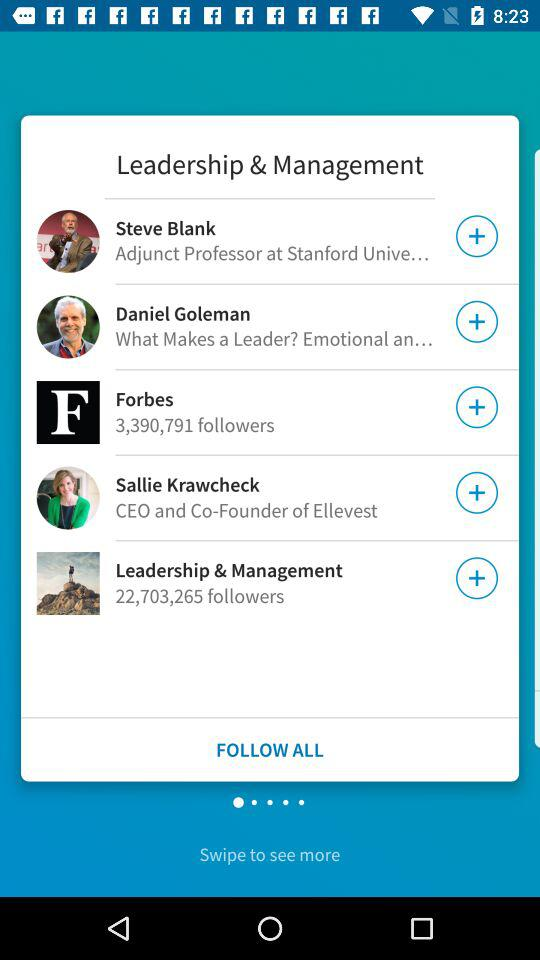Who is the CEO and Co-Founder of "Ellevest"? The CEO and Co-Founder of "Ellevest" is Sallie Krawcheck. 